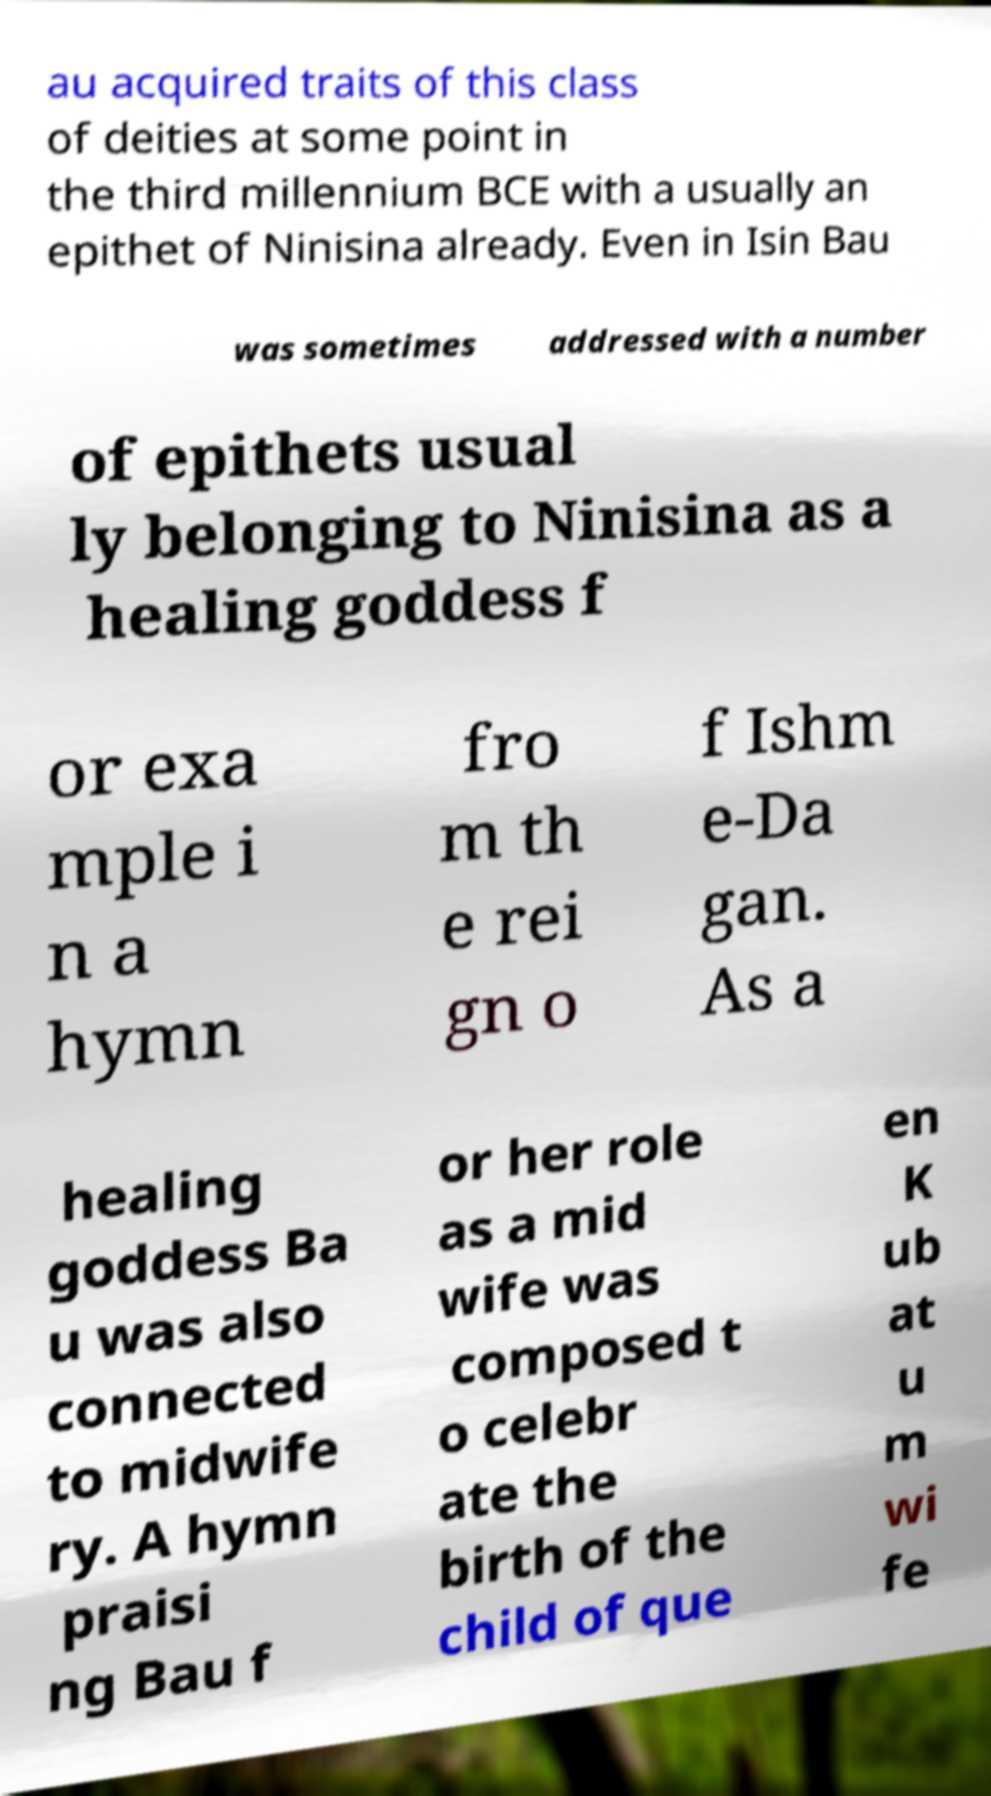Could you extract and type out the text from this image? au acquired traits of this class of deities at some point in the third millennium BCE with a usually an epithet of Ninisina already. Even in Isin Bau was sometimes addressed with a number of epithets usual ly belonging to Ninisina as a healing goddess f or exa mple i n a hymn fro m th e rei gn o f Ishm e-Da gan. As a healing goddess Ba u was also connected to midwife ry. A hymn praisi ng Bau f or her role as a mid wife was composed t o celebr ate the birth of the child of que en K ub at u m wi fe 